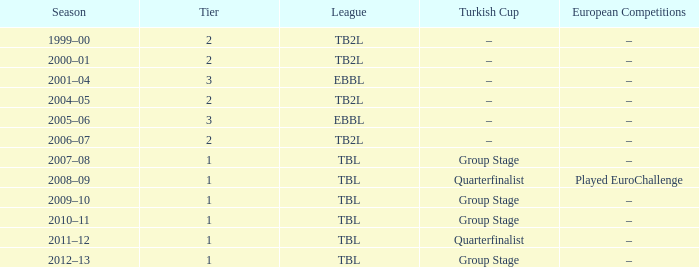Which league is the 2012-13 season? TBL. 